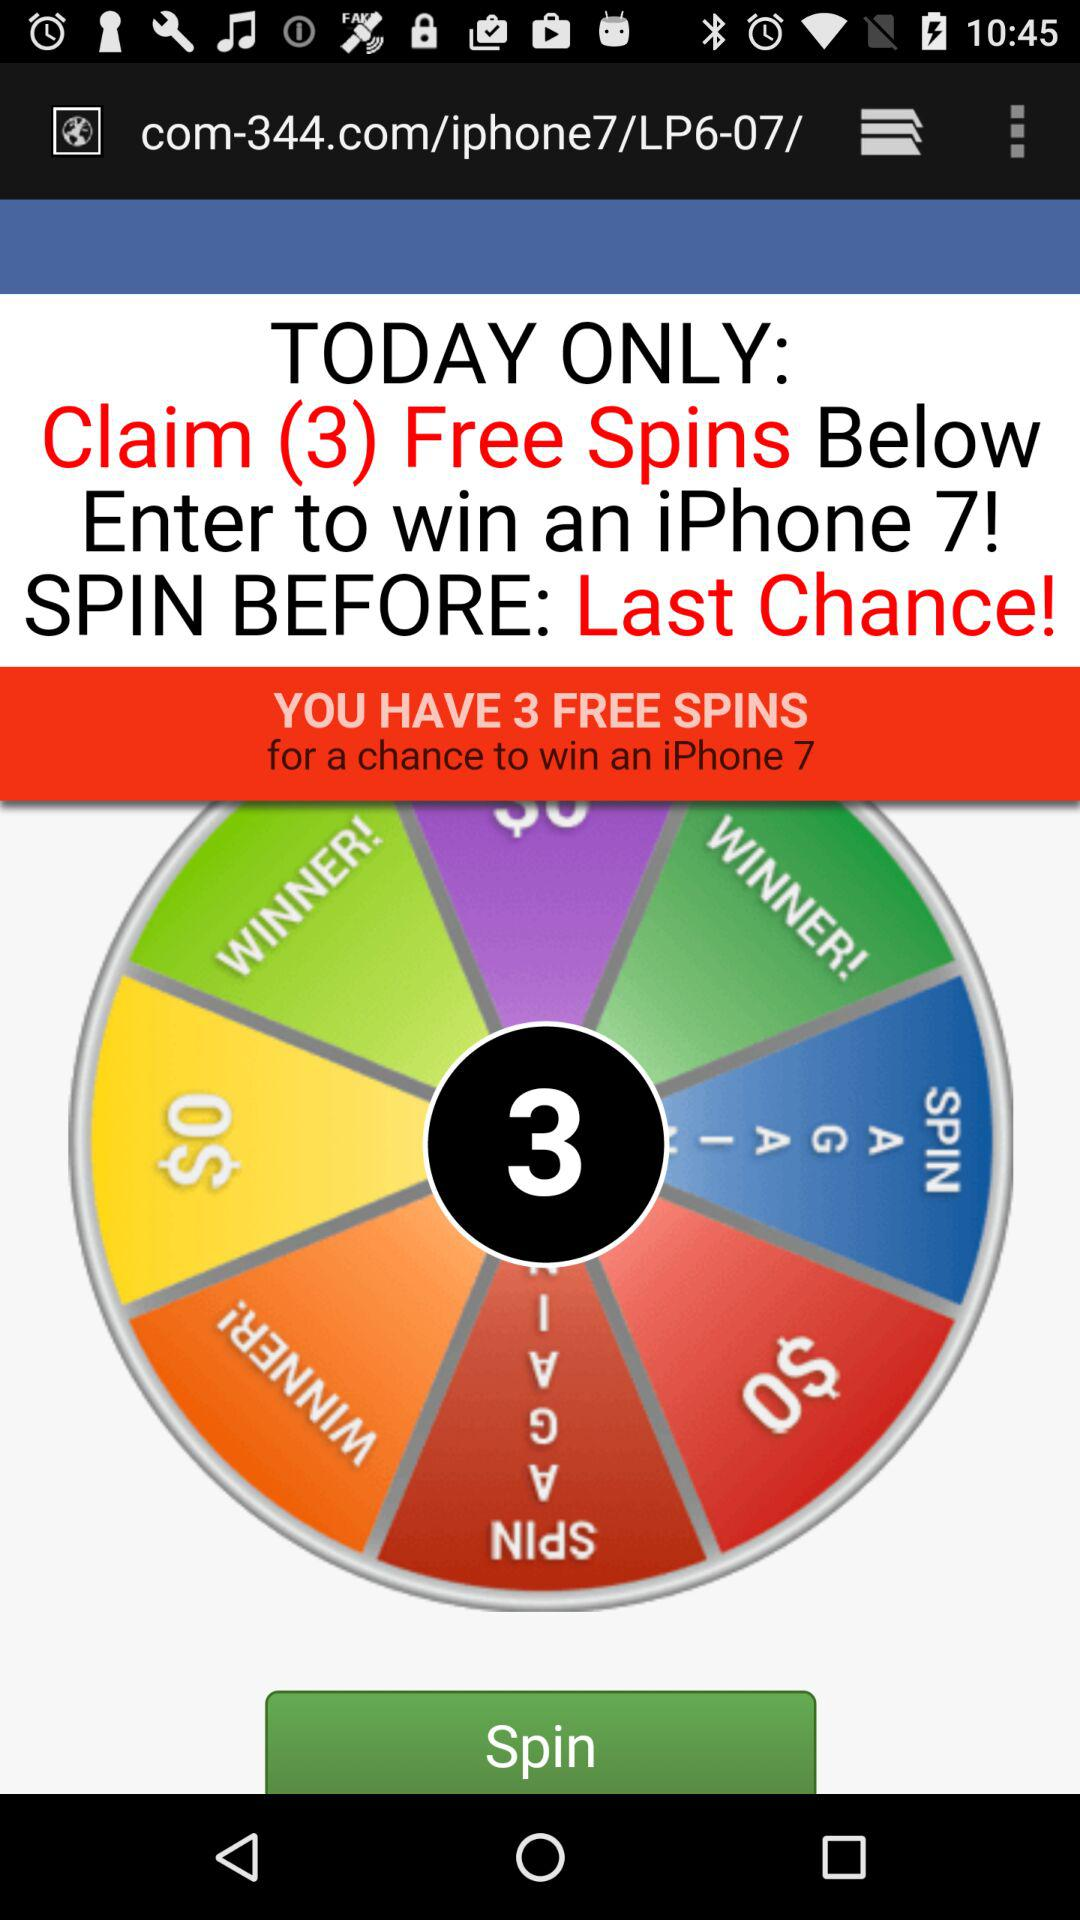What phone has a chance to be won? The phone that has a chance to be won is "iPhone 7". 